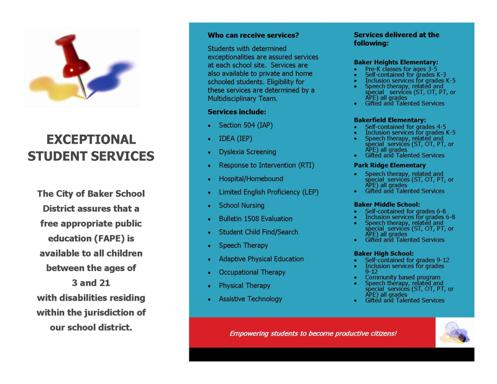Can you explain what Section 504 and IDEA are, as mentioned on the card? Certainly! Section 504 refers to a civil rights law that prevents discrimination against individuals with disabilities, ensuring that any child with a disability has equal access to education. IDEA, or the Individuals with Disabilities Education Act, mandates that public schools provide free special education and related services tailored to the individual needs of eligible children with disabilities, promoting their educational development. 